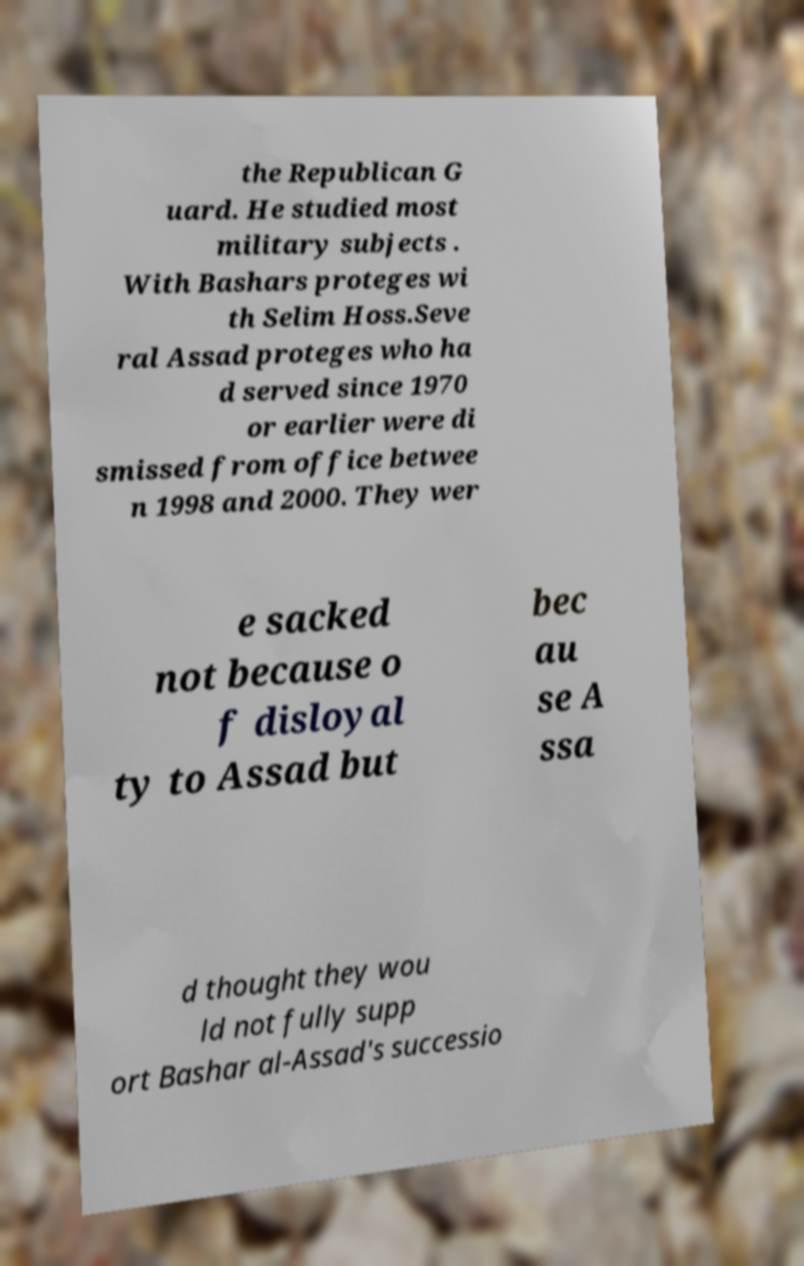Can you accurately transcribe the text from the provided image for me? the Republican G uard. He studied most military subjects . With Bashars proteges wi th Selim Hoss.Seve ral Assad proteges who ha d served since 1970 or earlier were di smissed from office betwee n 1998 and 2000. They wer e sacked not because o f disloyal ty to Assad but bec au se A ssa d thought they wou ld not fully supp ort Bashar al-Assad's successio 